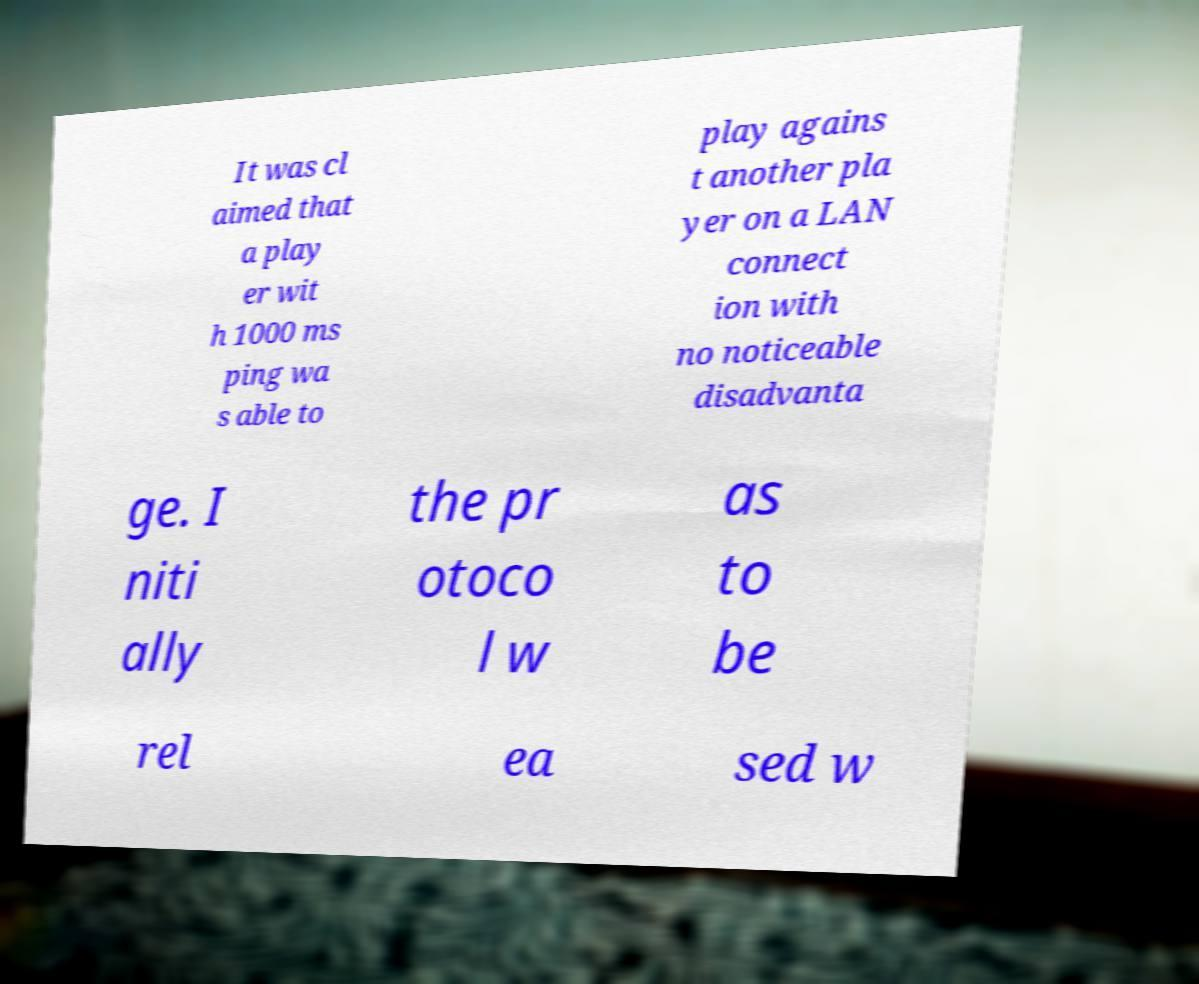For documentation purposes, I need the text within this image transcribed. Could you provide that? It was cl aimed that a play er wit h 1000 ms ping wa s able to play agains t another pla yer on a LAN connect ion with no noticeable disadvanta ge. I niti ally the pr otoco l w as to be rel ea sed w 